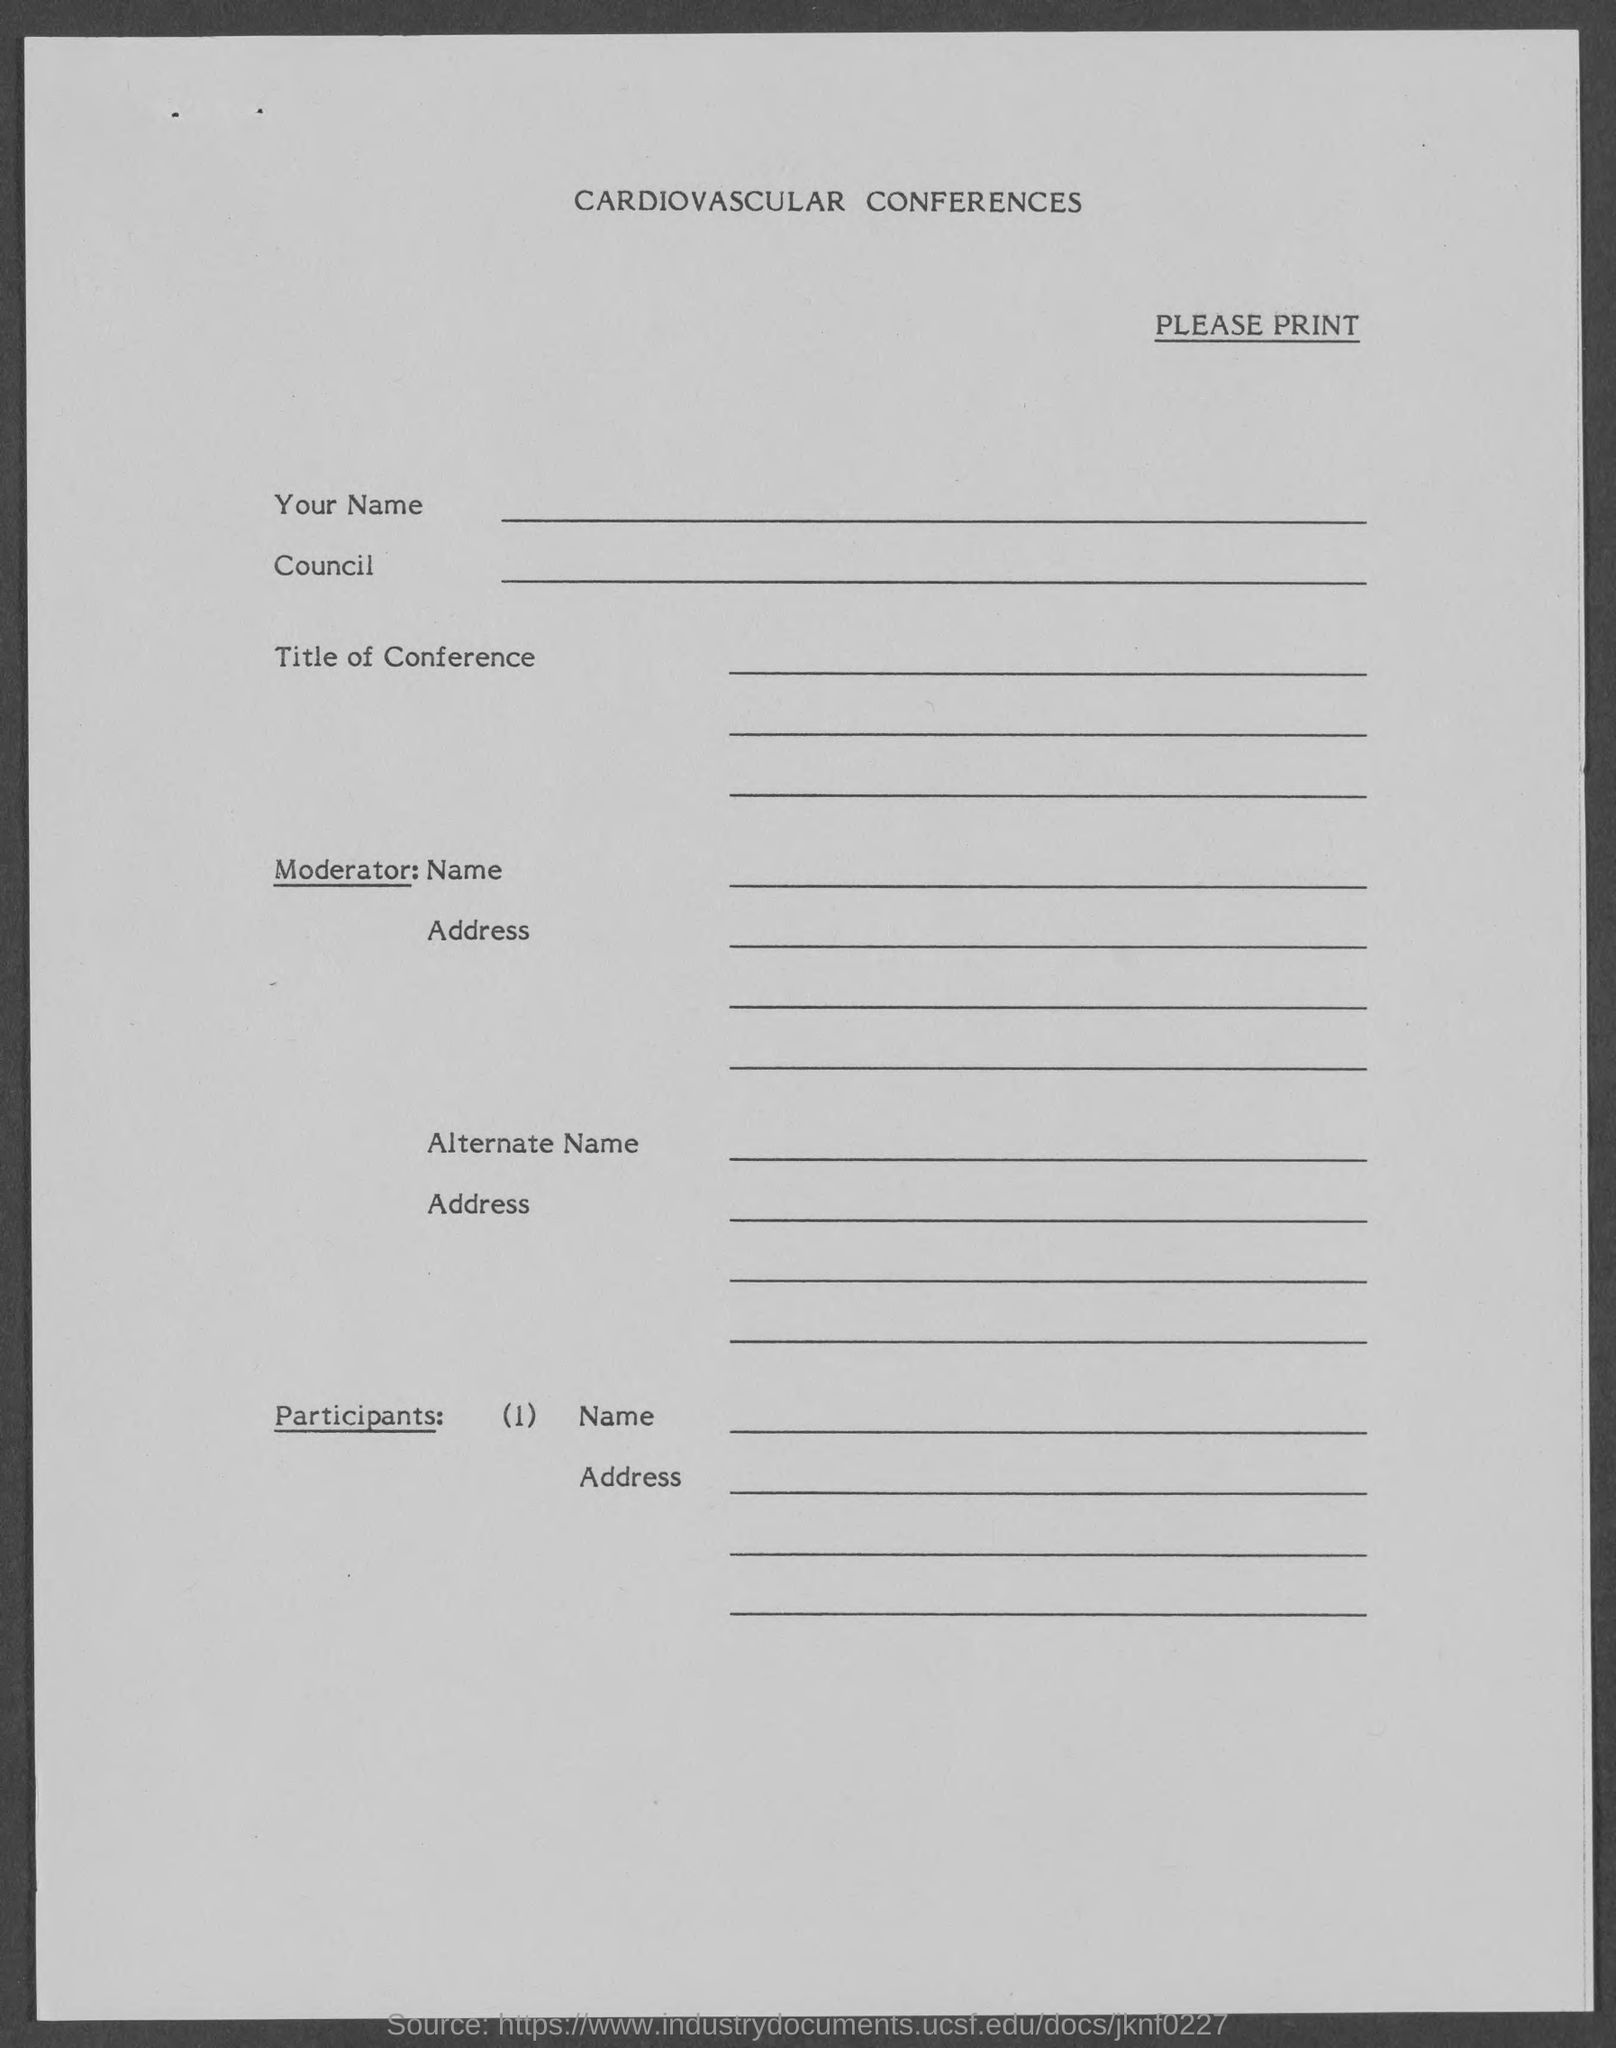What is the document title?
Make the answer very short. Cardiovascular Conferences. 